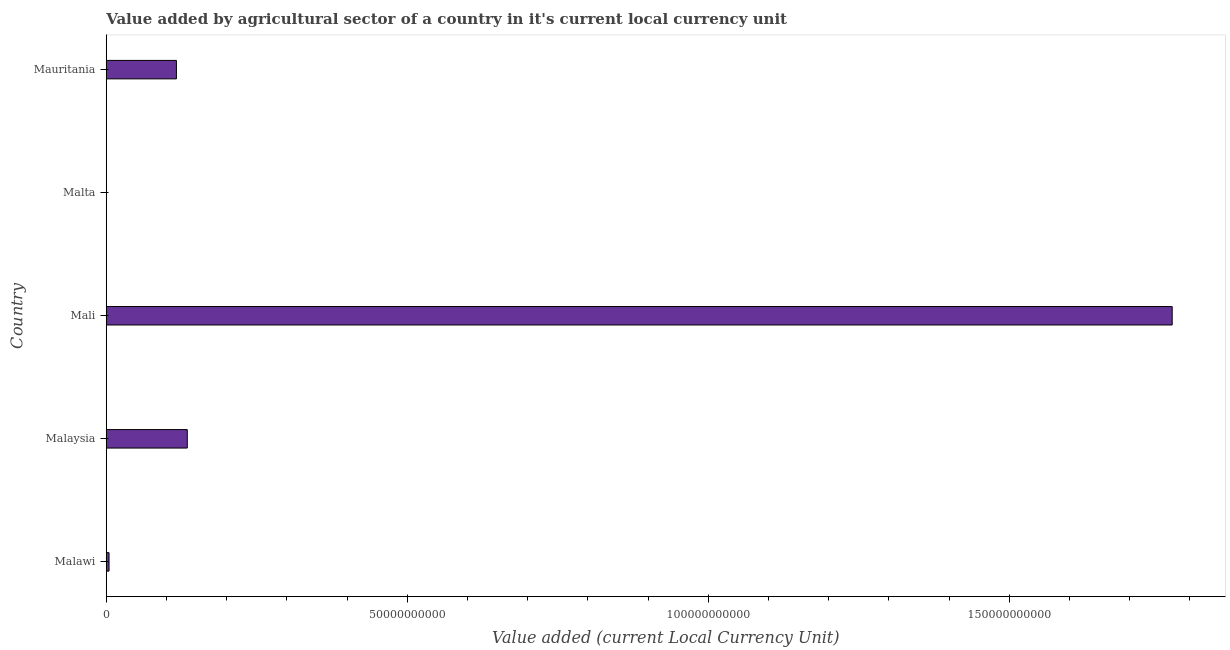Does the graph contain any zero values?
Ensure brevity in your answer.  No. Does the graph contain grids?
Keep it short and to the point. No. What is the title of the graph?
Give a very brief answer. Value added by agricultural sector of a country in it's current local currency unit. What is the label or title of the X-axis?
Your answer should be very brief. Value added (current Local Currency Unit). What is the label or title of the Y-axis?
Your response must be concise. Country. What is the value added by agriculture sector in Malta?
Give a very brief answer. 4.42e+07. Across all countries, what is the maximum value added by agriculture sector?
Your answer should be very brief. 1.77e+11. Across all countries, what is the minimum value added by agriculture sector?
Make the answer very short. 4.42e+07. In which country was the value added by agriculture sector maximum?
Keep it short and to the point. Mali. In which country was the value added by agriculture sector minimum?
Make the answer very short. Malta. What is the sum of the value added by agriculture sector?
Offer a terse response. 2.03e+11. What is the difference between the value added by agriculture sector in Malaysia and Mali?
Provide a short and direct response. -1.64e+11. What is the average value added by agriculture sector per country?
Offer a very short reply. 4.05e+1. What is the median value added by agriculture sector?
Your answer should be compact. 1.17e+1. What is the ratio of the value added by agriculture sector in Malawi to that in Mali?
Your answer should be compact. 0. What is the difference between the highest and the second highest value added by agriculture sector?
Make the answer very short. 1.64e+11. Is the sum of the value added by agriculture sector in Malaysia and Mali greater than the maximum value added by agriculture sector across all countries?
Keep it short and to the point. Yes. What is the difference between the highest and the lowest value added by agriculture sector?
Your response must be concise. 1.77e+11. Are all the bars in the graph horizontal?
Offer a very short reply. Yes. Are the values on the major ticks of X-axis written in scientific E-notation?
Provide a short and direct response. No. What is the Value added (current Local Currency Unit) in Malawi?
Provide a succinct answer. 4.64e+08. What is the Value added (current Local Currency Unit) of Malaysia?
Provide a succinct answer. 1.35e+1. What is the Value added (current Local Currency Unit) of Mali?
Make the answer very short. 1.77e+11. What is the Value added (current Local Currency Unit) of Malta?
Your response must be concise. 4.42e+07. What is the Value added (current Local Currency Unit) of Mauritania?
Offer a very short reply. 1.17e+1. What is the difference between the Value added (current Local Currency Unit) in Malawi and Malaysia?
Your response must be concise. -1.30e+1. What is the difference between the Value added (current Local Currency Unit) in Malawi and Mali?
Offer a very short reply. -1.77e+11. What is the difference between the Value added (current Local Currency Unit) in Malawi and Malta?
Provide a short and direct response. 4.20e+08. What is the difference between the Value added (current Local Currency Unit) in Malawi and Mauritania?
Provide a short and direct response. -1.12e+1. What is the difference between the Value added (current Local Currency Unit) in Malaysia and Mali?
Give a very brief answer. -1.64e+11. What is the difference between the Value added (current Local Currency Unit) in Malaysia and Malta?
Your answer should be compact. 1.34e+1. What is the difference between the Value added (current Local Currency Unit) in Malaysia and Mauritania?
Offer a terse response. 1.80e+09. What is the difference between the Value added (current Local Currency Unit) in Mali and Malta?
Your response must be concise. 1.77e+11. What is the difference between the Value added (current Local Currency Unit) in Mali and Mauritania?
Your answer should be very brief. 1.65e+11. What is the difference between the Value added (current Local Currency Unit) in Malta and Mauritania?
Provide a succinct answer. -1.16e+1. What is the ratio of the Value added (current Local Currency Unit) in Malawi to that in Malaysia?
Your answer should be very brief. 0.03. What is the ratio of the Value added (current Local Currency Unit) in Malawi to that in Mali?
Offer a terse response. 0. What is the ratio of the Value added (current Local Currency Unit) in Malawi to that in Malta?
Provide a short and direct response. 10.49. What is the ratio of the Value added (current Local Currency Unit) in Malawi to that in Mauritania?
Your response must be concise. 0.04. What is the ratio of the Value added (current Local Currency Unit) in Malaysia to that in Mali?
Provide a succinct answer. 0.08. What is the ratio of the Value added (current Local Currency Unit) in Malaysia to that in Malta?
Your answer should be compact. 304.41. What is the ratio of the Value added (current Local Currency Unit) in Malaysia to that in Mauritania?
Provide a succinct answer. 1.16. What is the ratio of the Value added (current Local Currency Unit) in Mali to that in Malta?
Offer a terse response. 4004.61. What is the ratio of the Value added (current Local Currency Unit) in Mali to that in Mauritania?
Your response must be concise. 15.19. What is the ratio of the Value added (current Local Currency Unit) in Malta to that in Mauritania?
Your response must be concise. 0. 